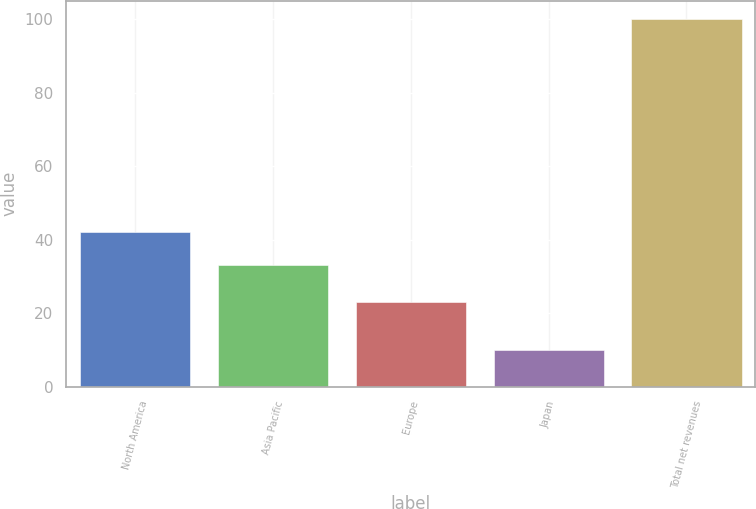Convert chart. <chart><loc_0><loc_0><loc_500><loc_500><bar_chart><fcel>North America<fcel>Asia Pacific<fcel>Europe<fcel>Japan<fcel>Total net revenues<nl><fcel>42<fcel>33<fcel>23<fcel>10<fcel>100<nl></chart> 